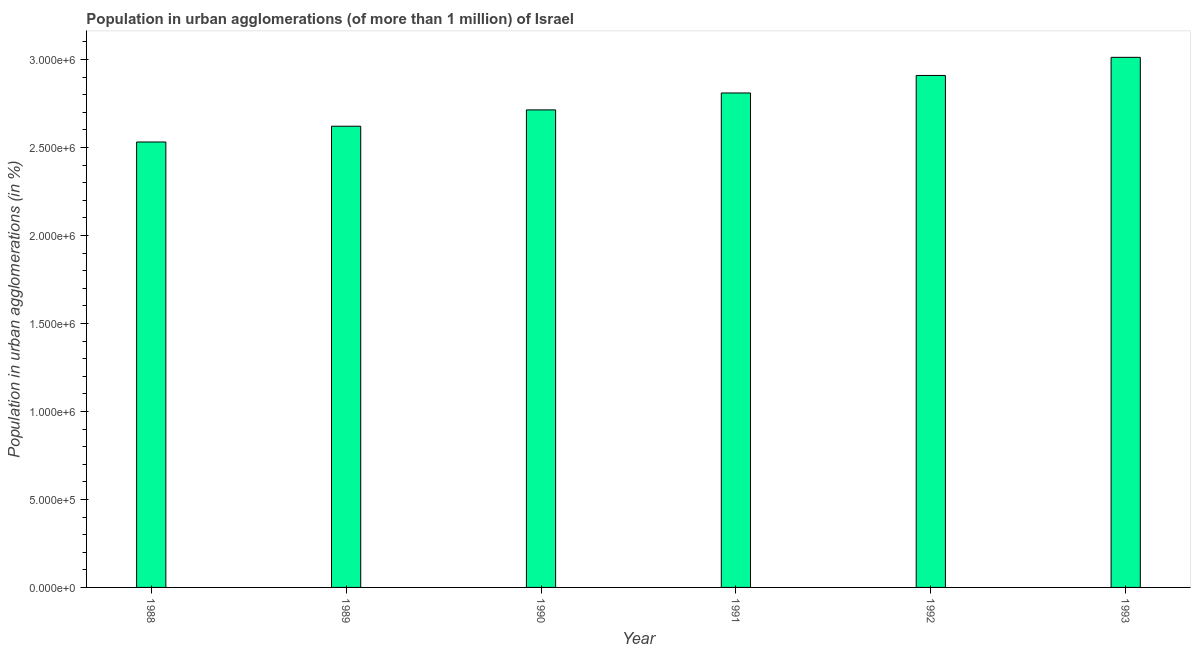Does the graph contain any zero values?
Your answer should be compact. No. What is the title of the graph?
Make the answer very short. Population in urban agglomerations (of more than 1 million) of Israel. What is the label or title of the Y-axis?
Keep it short and to the point. Population in urban agglomerations (in %). What is the population in urban agglomerations in 1990?
Give a very brief answer. 2.71e+06. Across all years, what is the maximum population in urban agglomerations?
Offer a very short reply. 3.01e+06. Across all years, what is the minimum population in urban agglomerations?
Offer a very short reply. 2.53e+06. In which year was the population in urban agglomerations maximum?
Provide a succinct answer. 1993. In which year was the population in urban agglomerations minimum?
Offer a very short reply. 1988. What is the sum of the population in urban agglomerations?
Your answer should be very brief. 1.66e+07. What is the difference between the population in urban agglomerations in 1991 and 1993?
Keep it short and to the point. -2.03e+05. What is the average population in urban agglomerations per year?
Make the answer very short. 2.77e+06. What is the median population in urban agglomerations?
Provide a short and direct response. 2.76e+06. In how many years, is the population in urban agglomerations greater than 600000 %?
Offer a very short reply. 6. Do a majority of the years between 1990 and 1992 (inclusive) have population in urban agglomerations greater than 200000 %?
Your response must be concise. Yes. What is the ratio of the population in urban agglomerations in 1989 to that in 1993?
Give a very brief answer. 0.87. Is the population in urban agglomerations in 1990 less than that in 1992?
Offer a very short reply. Yes. What is the difference between the highest and the second highest population in urban agglomerations?
Ensure brevity in your answer.  1.03e+05. What is the difference between the highest and the lowest population in urban agglomerations?
Keep it short and to the point. 4.81e+05. In how many years, is the population in urban agglomerations greater than the average population in urban agglomerations taken over all years?
Your answer should be compact. 3. Are all the bars in the graph horizontal?
Keep it short and to the point. No. What is the difference between two consecutive major ticks on the Y-axis?
Keep it short and to the point. 5.00e+05. What is the Population in urban agglomerations (in %) of 1988?
Offer a terse response. 2.53e+06. What is the Population in urban agglomerations (in %) of 1989?
Make the answer very short. 2.62e+06. What is the Population in urban agglomerations (in %) in 1990?
Your answer should be compact. 2.71e+06. What is the Population in urban agglomerations (in %) in 1991?
Offer a terse response. 2.81e+06. What is the Population in urban agglomerations (in %) of 1992?
Offer a very short reply. 2.91e+06. What is the Population in urban agglomerations (in %) of 1993?
Your answer should be compact. 3.01e+06. What is the difference between the Population in urban agglomerations (in %) in 1988 and 1989?
Your response must be concise. -8.95e+04. What is the difference between the Population in urban agglomerations (in %) in 1988 and 1990?
Your answer should be compact. -1.82e+05. What is the difference between the Population in urban agglomerations (in %) in 1988 and 1991?
Offer a very short reply. -2.78e+05. What is the difference between the Population in urban agglomerations (in %) in 1988 and 1992?
Your answer should be very brief. -3.78e+05. What is the difference between the Population in urban agglomerations (in %) in 1988 and 1993?
Offer a very short reply. -4.81e+05. What is the difference between the Population in urban agglomerations (in %) in 1989 and 1990?
Offer a terse response. -9.28e+04. What is the difference between the Population in urban agglomerations (in %) in 1989 and 1991?
Provide a succinct answer. -1.89e+05. What is the difference between the Population in urban agglomerations (in %) in 1989 and 1992?
Provide a short and direct response. -2.89e+05. What is the difference between the Population in urban agglomerations (in %) in 1989 and 1993?
Your answer should be compact. -3.91e+05. What is the difference between the Population in urban agglomerations (in %) in 1990 and 1991?
Your answer should be compact. -9.61e+04. What is the difference between the Population in urban agglomerations (in %) in 1990 and 1992?
Your response must be concise. -1.96e+05. What is the difference between the Population in urban agglomerations (in %) in 1990 and 1993?
Your answer should be very brief. -2.99e+05. What is the difference between the Population in urban agglomerations (in %) in 1991 and 1992?
Give a very brief answer. -9.96e+04. What is the difference between the Population in urban agglomerations (in %) in 1991 and 1993?
Your answer should be very brief. -2.03e+05. What is the difference between the Population in urban agglomerations (in %) in 1992 and 1993?
Provide a succinct answer. -1.03e+05. What is the ratio of the Population in urban agglomerations (in %) in 1988 to that in 1989?
Your response must be concise. 0.97. What is the ratio of the Population in urban agglomerations (in %) in 1988 to that in 1990?
Give a very brief answer. 0.93. What is the ratio of the Population in urban agglomerations (in %) in 1988 to that in 1991?
Provide a short and direct response. 0.9. What is the ratio of the Population in urban agglomerations (in %) in 1988 to that in 1992?
Give a very brief answer. 0.87. What is the ratio of the Population in urban agglomerations (in %) in 1988 to that in 1993?
Provide a succinct answer. 0.84. What is the ratio of the Population in urban agglomerations (in %) in 1989 to that in 1990?
Offer a very short reply. 0.97. What is the ratio of the Population in urban agglomerations (in %) in 1989 to that in 1991?
Make the answer very short. 0.93. What is the ratio of the Population in urban agglomerations (in %) in 1989 to that in 1992?
Provide a short and direct response. 0.9. What is the ratio of the Population in urban agglomerations (in %) in 1989 to that in 1993?
Provide a succinct answer. 0.87. What is the ratio of the Population in urban agglomerations (in %) in 1990 to that in 1991?
Your answer should be compact. 0.97. What is the ratio of the Population in urban agglomerations (in %) in 1990 to that in 1992?
Offer a terse response. 0.93. What is the ratio of the Population in urban agglomerations (in %) in 1990 to that in 1993?
Your answer should be compact. 0.9. What is the ratio of the Population in urban agglomerations (in %) in 1991 to that in 1992?
Offer a very short reply. 0.97. What is the ratio of the Population in urban agglomerations (in %) in 1991 to that in 1993?
Offer a terse response. 0.93. What is the ratio of the Population in urban agglomerations (in %) in 1992 to that in 1993?
Provide a short and direct response. 0.97. 